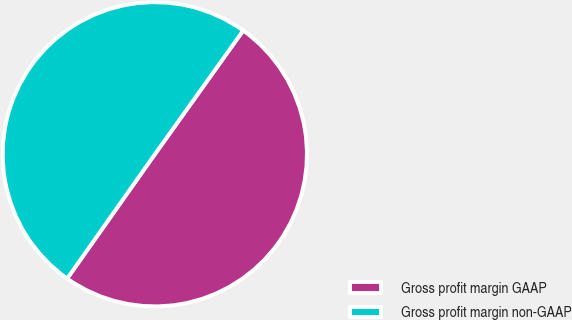<chart> <loc_0><loc_0><loc_500><loc_500><pie_chart><fcel>Gross profit margin GAAP<fcel>Gross profit margin non-GAAP<nl><fcel>49.91%<fcel>50.09%<nl></chart> 